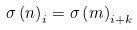Convert formula to latex. <formula><loc_0><loc_0><loc_500><loc_500>\sigma \left ( n \right ) _ { i } = \sigma \left ( m \right ) _ { i + k }</formula> 